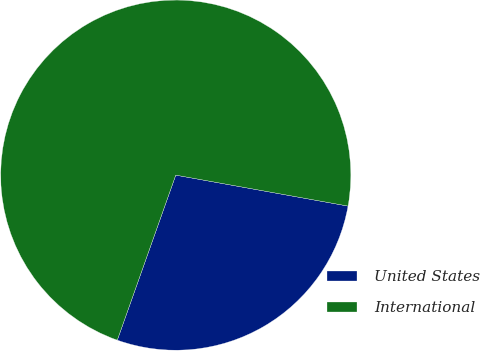Convert chart to OTSL. <chart><loc_0><loc_0><loc_500><loc_500><pie_chart><fcel>United States<fcel>International<nl><fcel>27.59%<fcel>72.41%<nl></chart> 